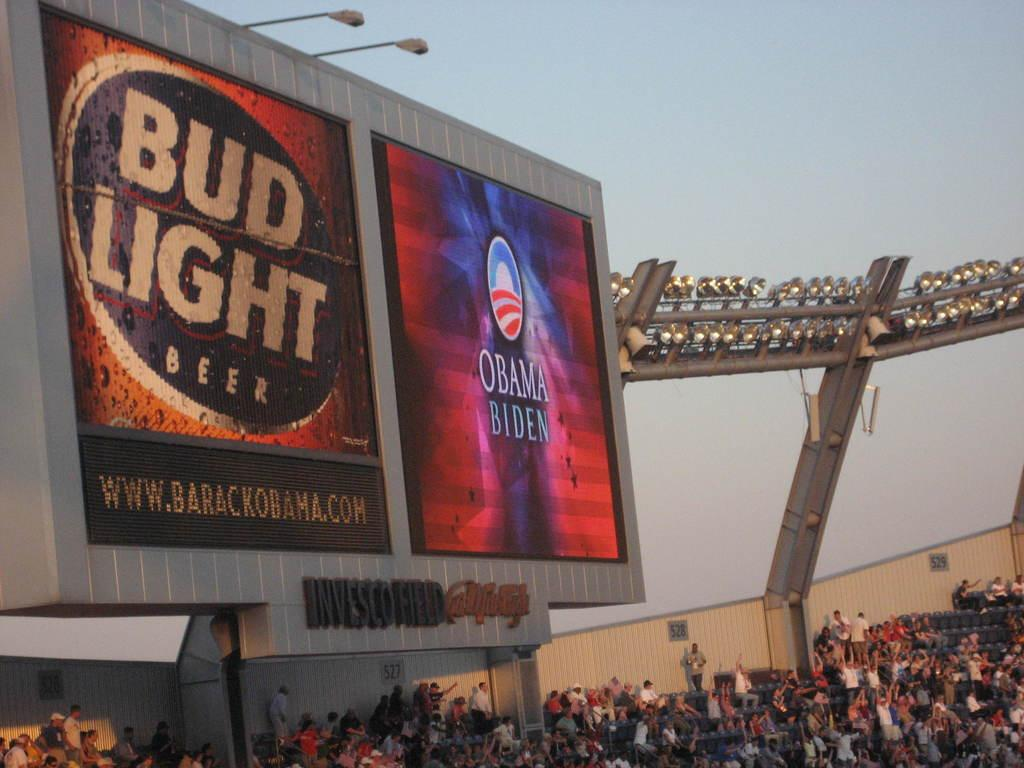Provide a one-sentence caption for the provided image. Bud light beer and a obama sign on a board with people looking at it. 